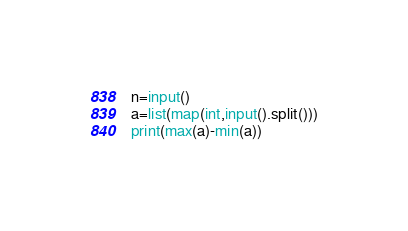Convert code to text. <code><loc_0><loc_0><loc_500><loc_500><_Python_>n=input()
a=list(map(int,input().split()))
print(max(a)-min(a))</code> 